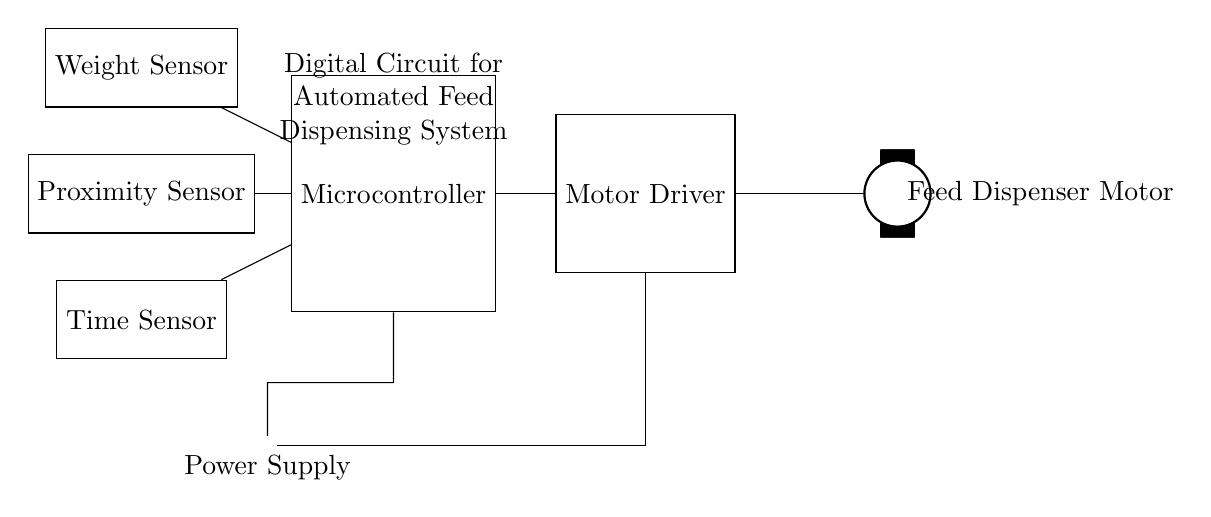What is the primary purpose of the microcontroller in this circuit? The microcontroller is responsible for processing inputs from the sensors and controlling the motor driver's operation. It orchestrates the automated feed dispensing based on conditions from the sensors.
Answer: Processing inputs What type of sensors are used in this circuitry? The circuit includes three types of sensors: weight sensor, proximity sensor, and time sensor, which help monitor different conditions for feed dispensing.
Answer: Three types Which component connects the microcontroller to the feed dispenser motor? The motor driver acts as an intermediary between the microcontroller and the feed dispenser motor, translating control signals into motor actions.
Answer: Motor driver What indicates the power supply in the circuit? The power supply is indicated by the battery symbol, which provides the necessary voltage and current for the operation of all components in the circuit.
Answer: Battery Which sensor would primarily determine when to dispense feed? The weight sensor is vital for determining whether the correct amount of feed has been dispensed or if more is needed, making it essential for the automated process.
Answer: Weight sensor How does the proximity sensor contribute to the system's automation? The proximity sensor helps ensure that the feed dispensing does not occur when the feed receptacle is obstructed or too close, preventing clogging or spillage, thereby enhancing safety and efficiency.
Answer: Prevents clogging What is the role of the time sensor in this automated feed dispensing system? The time sensor may be used to trigger feed dispensing at specific times or intervals, thus improving the feeding schedule for livestock, ensuring a timely feeding process.
Answer: Triggers feeding schedule 